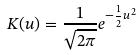Convert formula to latex. <formula><loc_0><loc_0><loc_500><loc_500>K ( u ) = \frac { 1 } { \sqrt { 2 \pi } } e ^ { - \frac { 1 } { 2 } u ^ { 2 } }</formula> 